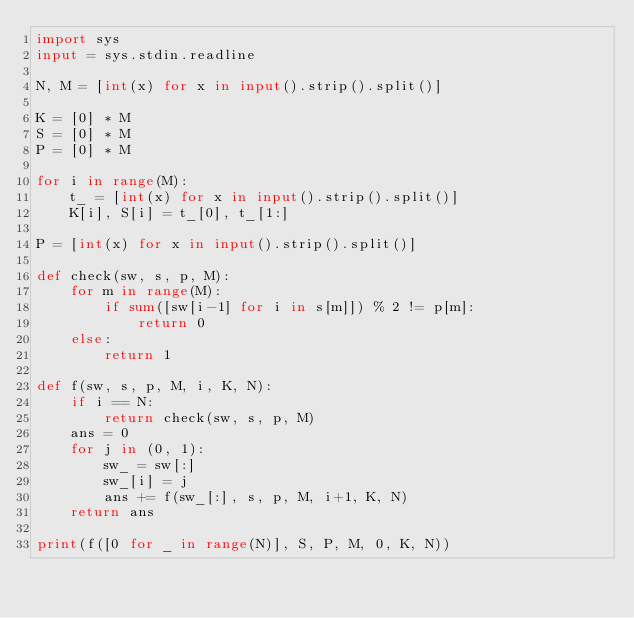Convert code to text. <code><loc_0><loc_0><loc_500><loc_500><_Python_>import sys
input = sys.stdin.readline

N, M = [int(x) for x in input().strip().split()]

K = [0] * M
S = [0] * M
P = [0] * M

for i in range(M):
    t_ = [int(x) for x in input().strip().split()]
    K[i], S[i] = t_[0], t_[1:]

P = [int(x) for x in input().strip().split()]

def check(sw, s, p, M):
    for m in range(M):
        if sum([sw[i-1] for i in s[m]]) % 2 != p[m]:
            return 0
    else:
        return 1

def f(sw, s, p, M, i, K, N):
    if i == N:
        return check(sw, s, p, M)
    ans = 0
    for j in (0, 1):
        sw_ = sw[:]
        sw_[i] = j
        ans += f(sw_[:], s, p, M, i+1, K, N)
    return ans

print(f([0 for _ in range(N)], S, P, M, 0, K, N))</code> 